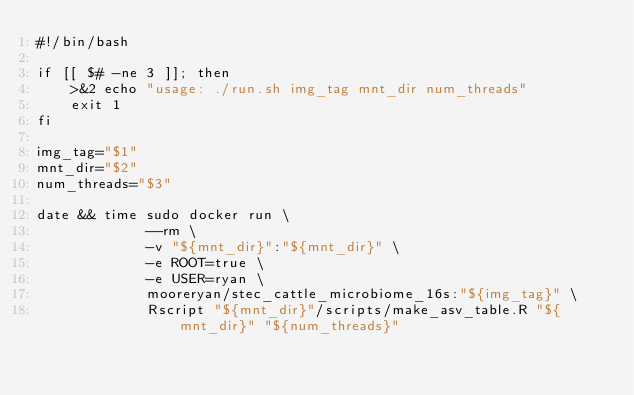<code> <loc_0><loc_0><loc_500><loc_500><_Bash_>#!/bin/bash

if [[ $# -ne 3 ]]; then
    >&2 echo "usage: ./run.sh img_tag mnt_dir num_threads"
    exit 1
fi

img_tag="$1"
mnt_dir="$2"
num_threads="$3"

date && time sudo docker run \
             --rm \
             -v "${mnt_dir}":"${mnt_dir}" \
             -e ROOT=true \
             -e USER=ryan \
             mooreryan/stec_cattle_microbiome_16s:"${img_tag}" \
             Rscript "${mnt_dir}"/scripts/make_asv_table.R "${mnt_dir}" "${num_threads}"
</code> 